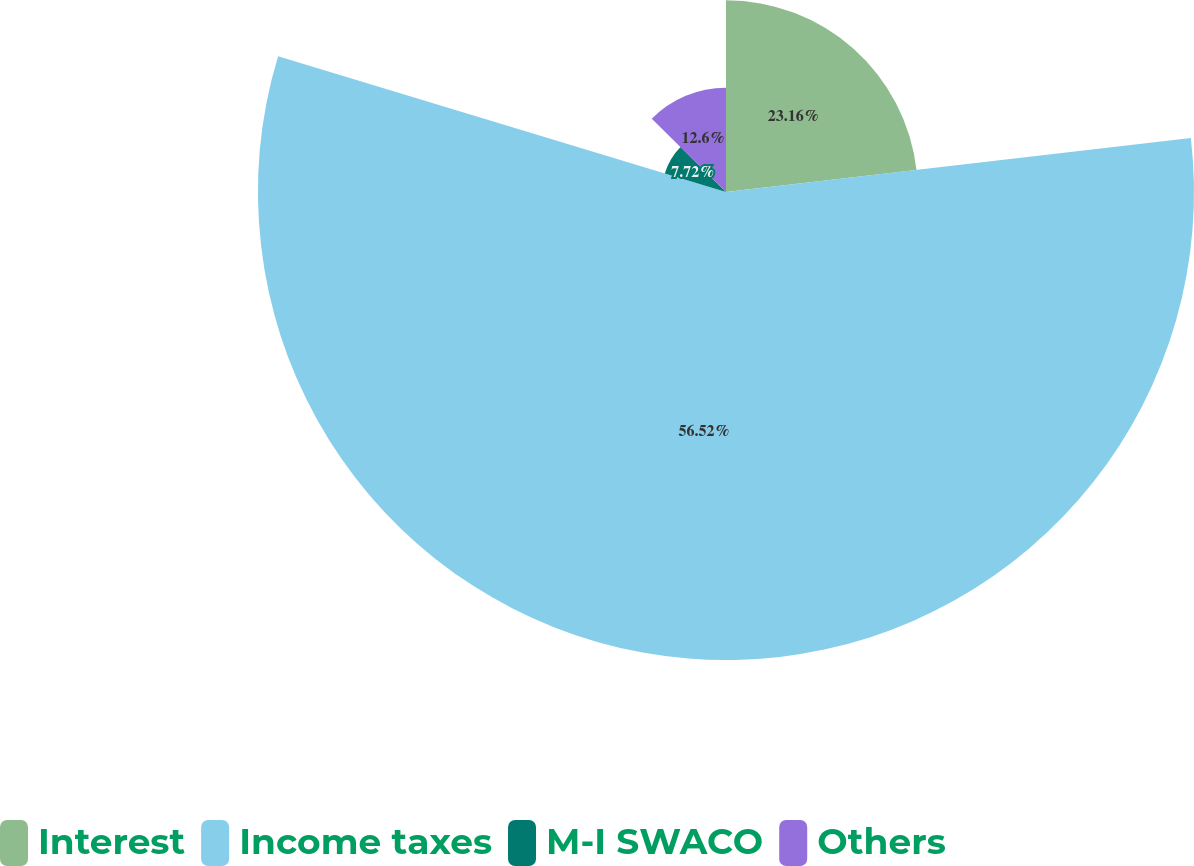Convert chart to OTSL. <chart><loc_0><loc_0><loc_500><loc_500><pie_chart><fcel>Interest<fcel>Income taxes<fcel>M-I SWACO<fcel>Others<nl><fcel>23.16%<fcel>56.52%<fcel>7.72%<fcel>12.6%<nl></chart> 